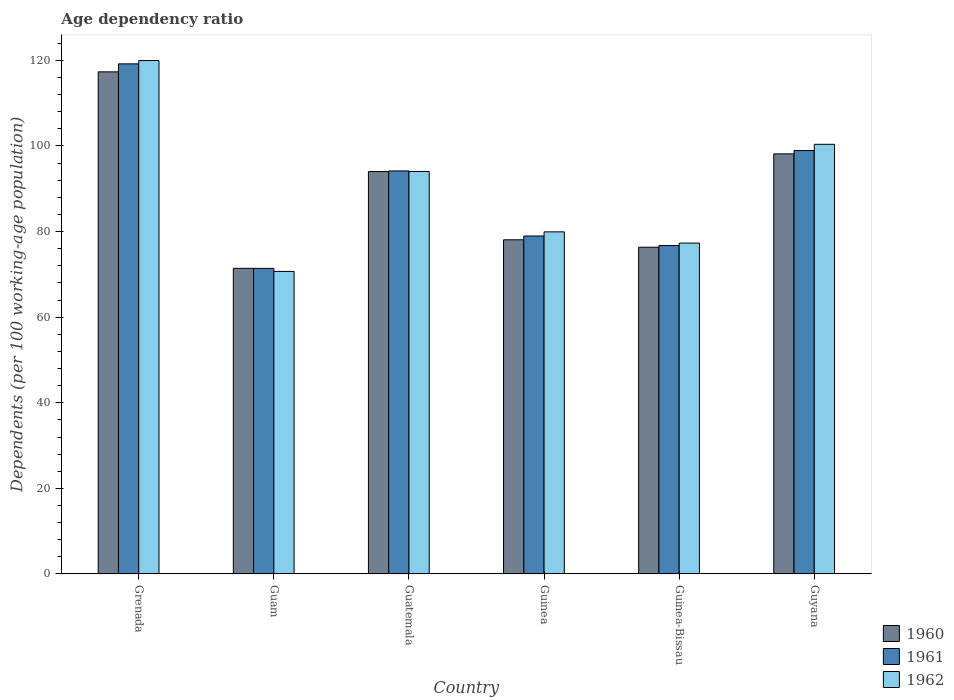How many different coloured bars are there?
Your response must be concise. 3. How many groups of bars are there?
Provide a short and direct response. 6. How many bars are there on the 1st tick from the left?
Offer a terse response. 3. What is the label of the 4th group of bars from the left?
Your answer should be very brief. Guinea. In how many cases, is the number of bars for a given country not equal to the number of legend labels?
Offer a terse response. 0. What is the age dependency ratio in in 1962 in Guinea-Bissau?
Keep it short and to the point. 77.32. Across all countries, what is the maximum age dependency ratio in in 1961?
Provide a short and direct response. 119.19. Across all countries, what is the minimum age dependency ratio in in 1961?
Give a very brief answer. 71.4. In which country was the age dependency ratio in in 1962 maximum?
Your answer should be compact. Grenada. In which country was the age dependency ratio in in 1960 minimum?
Provide a succinct answer. Guam. What is the total age dependency ratio in in 1961 in the graph?
Your answer should be very brief. 539.4. What is the difference between the age dependency ratio in in 1962 in Guam and that in Guinea-Bissau?
Your response must be concise. -6.62. What is the difference between the age dependency ratio in in 1962 in Guinea-Bissau and the age dependency ratio in in 1960 in Grenada?
Your answer should be compact. -40.01. What is the average age dependency ratio in in 1961 per country?
Your answer should be very brief. 89.9. What is the difference between the age dependency ratio in of/in 1961 and age dependency ratio in of/in 1960 in Grenada?
Make the answer very short. 1.87. What is the ratio of the age dependency ratio in in 1961 in Guam to that in Guatemala?
Give a very brief answer. 0.76. Is the age dependency ratio in in 1961 in Guinea less than that in Guyana?
Your response must be concise. Yes. What is the difference between the highest and the second highest age dependency ratio in in 1962?
Your answer should be compact. 6.35. What is the difference between the highest and the lowest age dependency ratio in in 1962?
Your answer should be very brief. 49.27. What does the 2nd bar from the right in Guinea represents?
Provide a succinct answer. 1961. Is it the case that in every country, the sum of the age dependency ratio in in 1961 and age dependency ratio in in 1960 is greater than the age dependency ratio in in 1962?
Offer a terse response. Yes. How many bars are there?
Offer a terse response. 18. Are all the bars in the graph horizontal?
Ensure brevity in your answer.  No. How many countries are there in the graph?
Make the answer very short. 6. Does the graph contain grids?
Ensure brevity in your answer.  No. What is the title of the graph?
Offer a very short reply. Age dependency ratio. What is the label or title of the X-axis?
Your answer should be compact. Country. What is the label or title of the Y-axis?
Give a very brief answer. Dependents (per 100 working-age population). What is the Dependents (per 100 working-age population) in 1960 in Grenada?
Ensure brevity in your answer.  117.32. What is the Dependents (per 100 working-age population) in 1961 in Grenada?
Make the answer very short. 119.19. What is the Dependents (per 100 working-age population) of 1962 in Grenada?
Your response must be concise. 119.96. What is the Dependents (per 100 working-age population) in 1960 in Guam?
Make the answer very short. 71.41. What is the Dependents (per 100 working-age population) in 1961 in Guam?
Your response must be concise. 71.4. What is the Dependents (per 100 working-age population) of 1962 in Guam?
Keep it short and to the point. 70.69. What is the Dependents (per 100 working-age population) in 1960 in Guatemala?
Your answer should be compact. 94.02. What is the Dependents (per 100 working-age population) of 1961 in Guatemala?
Keep it short and to the point. 94.17. What is the Dependents (per 100 working-age population) in 1962 in Guatemala?
Give a very brief answer. 94.05. What is the Dependents (per 100 working-age population) in 1960 in Guinea?
Give a very brief answer. 78.08. What is the Dependents (per 100 working-age population) in 1961 in Guinea?
Offer a terse response. 78.97. What is the Dependents (per 100 working-age population) of 1962 in Guinea?
Keep it short and to the point. 79.94. What is the Dependents (per 100 working-age population) of 1960 in Guinea-Bissau?
Keep it short and to the point. 76.34. What is the Dependents (per 100 working-age population) of 1961 in Guinea-Bissau?
Offer a very short reply. 76.74. What is the Dependents (per 100 working-age population) of 1962 in Guinea-Bissau?
Offer a very short reply. 77.32. What is the Dependents (per 100 working-age population) in 1960 in Guyana?
Give a very brief answer. 98.15. What is the Dependents (per 100 working-age population) in 1961 in Guyana?
Provide a short and direct response. 98.93. What is the Dependents (per 100 working-age population) in 1962 in Guyana?
Offer a terse response. 100.39. Across all countries, what is the maximum Dependents (per 100 working-age population) of 1960?
Your response must be concise. 117.32. Across all countries, what is the maximum Dependents (per 100 working-age population) of 1961?
Your answer should be compact. 119.19. Across all countries, what is the maximum Dependents (per 100 working-age population) in 1962?
Keep it short and to the point. 119.96. Across all countries, what is the minimum Dependents (per 100 working-age population) of 1960?
Offer a terse response. 71.41. Across all countries, what is the minimum Dependents (per 100 working-age population) of 1961?
Offer a terse response. 71.4. Across all countries, what is the minimum Dependents (per 100 working-age population) of 1962?
Offer a terse response. 70.69. What is the total Dependents (per 100 working-age population) in 1960 in the graph?
Your answer should be compact. 535.34. What is the total Dependents (per 100 working-age population) of 1961 in the graph?
Keep it short and to the point. 539.4. What is the total Dependents (per 100 working-age population) in 1962 in the graph?
Keep it short and to the point. 542.35. What is the difference between the Dependents (per 100 working-age population) in 1960 in Grenada and that in Guam?
Ensure brevity in your answer.  45.91. What is the difference between the Dependents (per 100 working-age population) in 1961 in Grenada and that in Guam?
Ensure brevity in your answer.  47.79. What is the difference between the Dependents (per 100 working-age population) in 1962 in Grenada and that in Guam?
Your response must be concise. 49.27. What is the difference between the Dependents (per 100 working-age population) of 1960 in Grenada and that in Guatemala?
Your answer should be very brief. 23.3. What is the difference between the Dependents (per 100 working-age population) in 1961 in Grenada and that in Guatemala?
Offer a terse response. 25.02. What is the difference between the Dependents (per 100 working-age population) of 1962 in Grenada and that in Guatemala?
Provide a short and direct response. 25.92. What is the difference between the Dependents (per 100 working-age population) in 1960 in Grenada and that in Guinea?
Your answer should be very brief. 39.24. What is the difference between the Dependents (per 100 working-age population) of 1961 in Grenada and that in Guinea?
Keep it short and to the point. 40.22. What is the difference between the Dependents (per 100 working-age population) of 1962 in Grenada and that in Guinea?
Keep it short and to the point. 40.03. What is the difference between the Dependents (per 100 working-age population) in 1960 in Grenada and that in Guinea-Bissau?
Make the answer very short. 40.98. What is the difference between the Dependents (per 100 working-age population) in 1961 in Grenada and that in Guinea-Bissau?
Keep it short and to the point. 42.46. What is the difference between the Dependents (per 100 working-age population) in 1962 in Grenada and that in Guinea-Bissau?
Keep it short and to the point. 42.65. What is the difference between the Dependents (per 100 working-age population) of 1960 in Grenada and that in Guyana?
Provide a succinct answer. 19.17. What is the difference between the Dependents (per 100 working-age population) in 1961 in Grenada and that in Guyana?
Provide a succinct answer. 20.26. What is the difference between the Dependents (per 100 working-age population) of 1962 in Grenada and that in Guyana?
Offer a very short reply. 19.57. What is the difference between the Dependents (per 100 working-age population) of 1960 in Guam and that in Guatemala?
Your response must be concise. -22.61. What is the difference between the Dependents (per 100 working-age population) of 1961 in Guam and that in Guatemala?
Offer a very short reply. -22.77. What is the difference between the Dependents (per 100 working-age population) in 1962 in Guam and that in Guatemala?
Your answer should be very brief. -23.35. What is the difference between the Dependents (per 100 working-age population) of 1960 in Guam and that in Guinea?
Make the answer very short. -6.67. What is the difference between the Dependents (per 100 working-age population) in 1961 in Guam and that in Guinea?
Keep it short and to the point. -7.57. What is the difference between the Dependents (per 100 working-age population) in 1962 in Guam and that in Guinea?
Offer a terse response. -9.24. What is the difference between the Dependents (per 100 working-age population) of 1960 in Guam and that in Guinea-Bissau?
Provide a succinct answer. -4.93. What is the difference between the Dependents (per 100 working-age population) in 1961 in Guam and that in Guinea-Bissau?
Provide a succinct answer. -5.33. What is the difference between the Dependents (per 100 working-age population) of 1962 in Guam and that in Guinea-Bissau?
Your response must be concise. -6.62. What is the difference between the Dependents (per 100 working-age population) in 1960 in Guam and that in Guyana?
Provide a succinct answer. -26.74. What is the difference between the Dependents (per 100 working-age population) in 1961 in Guam and that in Guyana?
Keep it short and to the point. -27.53. What is the difference between the Dependents (per 100 working-age population) in 1962 in Guam and that in Guyana?
Ensure brevity in your answer.  -29.7. What is the difference between the Dependents (per 100 working-age population) of 1960 in Guatemala and that in Guinea?
Your response must be concise. 15.94. What is the difference between the Dependents (per 100 working-age population) in 1961 in Guatemala and that in Guinea?
Make the answer very short. 15.2. What is the difference between the Dependents (per 100 working-age population) in 1962 in Guatemala and that in Guinea?
Your response must be concise. 14.11. What is the difference between the Dependents (per 100 working-age population) of 1960 in Guatemala and that in Guinea-Bissau?
Give a very brief answer. 17.68. What is the difference between the Dependents (per 100 working-age population) in 1961 in Guatemala and that in Guinea-Bissau?
Give a very brief answer. 17.44. What is the difference between the Dependents (per 100 working-age population) in 1962 in Guatemala and that in Guinea-Bissau?
Provide a succinct answer. 16.73. What is the difference between the Dependents (per 100 working-age population) in 1960 in Guatemala and that in Guyana?
Offer a very short reply. -4.13. What is the difference between the Dependents (per 100 working-age population) in 1961 in Guatemala and that in Guyana?
Provide a succinct answer. -4.76. What is the difference between the Dependents (per 100 working-age population) of 1962 in Guatemala and that in Guyana?
Offer a terse response. -6.35. What is the difference between the Dependents (per 100 working-age population) in 1960 in Guinea and that in Guinea-Bissau?
Your answer should be compact. 1.74. What is the difference between the Dependents (per 100 working-age population) in 1961 in Guinea and that in Guinea-Bissau?
Give a very brief answer. 2.24. What is the difference between the Dependents (per 100 working-age population) of 1962 in Guinea and that in Guinea-Bissau?
Provide a succinct answer. 2.62. What is the difference between the Dependents (per 100 working-age population) in 1960 in Guinea and that in Guyana?
Offer a terse response. -20.07. What is the difference between the Dependents (per 100 working-age population) of 1961 in Guinea and that in Guyana?
Offer a very short reply. -19.96. What is the difference between the Dependents (per 100 working-age population) of 1962 in Guinea and that in Guyana?
Ensure brevity in your answer.  -20.46. What is the difference between the Dependents (per 100 working-age population) in 1960 in Guinea-Bissau and that in Guyana?
Give a very brief answer. -21.81. What is the difference between the Dependents (per 100 working-age population) in 1961 in Guinea-Bissau and that in Guyana?
Make the answer very short. -22.19. What is the difference between the Dependents (per 100 working-age population) of 1962 in Guinea-Bissau and that in Guyana?
Provide a succinct answer. -23.08. What is the difference between the Dependents (per 100 working-age population) in 1960 in Grenada and the Dependents (per 100 working-age population) in 1961 in Guam?
Provide a short and direct response. 45.92. What is the difference between the Dependents (per 100 working-age population) in 1960 in Grenada and the Dependents (per 100 working-age population) in 1962 in Guam?
Make the answer very short. 46.63. What is the difference between the Dependents (per 100 working-age population) in 1961 in Grenada and the Dependents (per 100 working-age population) in 1962 in Guam?
Your answer should be very brief. 48.5. What is the difference between the Dependents (per 100 working-age population) of 1960 in Grenada and the Dependents (per 100 working-age population) of 1961 in Guatemala?
Keep it short and to the point. 23.15. What is the difference between the Dependents (per 100 working-age population) of 1960 in Grenada and the Dependents (per 100 working-age population) of 1962 in Guatemala?
Your answer should be very brief. 23.28. What is the difference between the Dependents (per 100 working-age population) of 1961 in Grenada and the Dependents (per 100 working-age population) of 1962 in Guatemala?
Ensure brevity in your answer.  25.14. What is the difference between the Dependents (per 100 working-age population) in 1960 in Grenada and the Dependents (per 100 working-age population) in 1961 in Guinea?
Provide a short and direct response. 38.35. What is the difference between the Dependents (per 100 working-age population) of 1960 in Grenada and the Dependents (per 100 working-age population) of 1962 in Guinea?
Give a very brief answer. 37.39. What is the difference between the Dependents (per 100 working-age population) of 1961 in Grenada and the Dependents (per 100 working-age population) of 1962 in Guinea?
Offer a very short reply. 39.25. What is the difference between the Dependents (per 100 working-age population) of 1960 in Grenada and the Dependents (per 100 working-age population) of 1961 in Guinea-Bissau?
Offer a terse response. 40.59. What is the difference between the Dependents (per 100 working-age population) of 1960 in Grenada and the Dependents (per 100 working-age population) of 1962 in Guinea-Bissau?
Offer a very short reply. 40.01. What is the difference between the Dependents (per 100 working-age population) in 1961 in Grenada and the Dependents (per 100 working-age population) in 1962 in Guinea-Bissau?
Make the answer very short. 41.87. What is the difference between the Dependents (per 100 working-age population) of 1960 in Grenada and the Dependents (per 100 working-age population) of 1961 in Guyana?
Give a very brief answer. 18.39. What is the difference between the Dependents (per 100 working-age population) in 1960 in Grenada and the Dependents (per 100 working-age population) in 1962 in Guyana?
Your answer should be very brief. 16.93. What is the difference between the Dependents (per 100 working-age population) of 1961 in Grenada and the Dependents (per 100 working-age population) of 1962 in Guyana?
Give a very brief answer. 18.8. What is the difference between the Dependents (per 100 working-age population) in 1960 in Guam and the Dependents (per 100 working-age population) in 1961 in Guatemala?
Ensure brevity in your answer.  -22.76. What is the difference between the Dependents (per 100 working-age population) in 1960 in Guam and the Dependents (per 100 working-age population) in 1962 in Guatemala?
Your answer should be compact. -22.63. What is the difference between the Dependents (per 100 working-age population) in 1961 in Guam and the Dependents (per 100 working-age population) in 1962 in Guatemala?
Offer a terse response. -22.64. What is the difference between the Dependents (per 100 working-age population) of 1960 in Guam and the Dependents (per 100 working-age population) of 1961 in Guinea?
Your response must be concise. -7.56. What is the difference between the Dependents (per 100 working-age population) in 1960 in Guam and the Dependents (per 100 working-age population) in 1962 in Guinea?
Make the answer very short. -8.52. What is the difference between the Dependents (per 100 working-age population) in 1961 in Guam and the Dependents (per 100 working-age population) in 1962 in Guinea?
Make the answer very short. -8.53. What is the difference between the Dependents (per 100 working-age population) in 1960 in Guam and the Dependents (per 100 working-age population) in 1961 in Guinea-Bissau?
Provide a succinct answer. -5.32. What is the difference between the Dependents (per 100 working-age population) in 1960 in Guam and the Dependents (per 100 working-age population) in 1962 in Guinea-Bissau?
Offer a very short reply. -5.91. What is the difference between the Dependents (per 100 working-age population) of 1961 in Guam and the Dependents (per 100 working-age population) of 1962 in Guinea-Bissau?
Your response must be concise. -5.91. What is the difference between the Dependents (per 100 working-age population) in 1960 in Guam and the Dependents (per 100 working-age population) in 1961 in Guyana?
Make the answer very short. -27.52. What is the difference between the Dependents (per 100 working-age population) of 1960 in Guam and the Dependents (per 100 working-age population) of 1962 in Guyana?
Your answer should be compact. -28.98. What is the difference between the Dependents (per 100 working-age population) of 1961 in Guam and the Dependents (per 100 working-age population) of 1962 in Guyana?
Give a very brief answer. -28.99. What is the difference between the Dependents (per 100 working-age population) in 1960 in Guatemala and the Dependents (per 100 working-age population) in 1961 in Guinea?
Make the answer very short. 15.05. What is the difference between the Dependents (per 100 working-age population) of 1960 in Guatemala and the Dependents (per 100 working-age population) of 1962 in Guinea?
Keep it short and to the point. 14.09. What is the difference between the Dependents (per 100 working-age population) of 1961 in Guatemala and the Dependents (per 100 working-age population) of 1962 in Guinea?
Your answer should be very brief. 14.23. What is the difference between the Dependents (per 100 working-age population) of 1960 in Guatemala and the Dependents (per 100 working-age population) of 1961 in Guinea-Bissau?
Your answer should be compact. 17.29. What is the difference between the Dependents (per 100 working-age population) in 1960 in Guatemala and the Dependents (per 100 working-age population) in 1962 in Guinea-Bissau?
Your response must be concise. 16.7. What is the difference between the Dependents (per 100 working-age population) in 1961 in Guatemala and the Dependents (per 100 working-age population) in 1962 in Guinea-Bissau?
Your answer should be compact. 16.85. What is the difference between the Dependents (per 100 working-age population) of 1960 in Guatemala and the Dependents (per 100 working-age population) of 1961 in Guyana?
Offer a very short reply. -4.91. What is the difference between the Dependents (per 100 working-age population) in 1960 in Guatemala and the Dependents (per 100 working-age population) in 1962 in Guyana?
Your response must be concise. -6.37. What is the difference between the Dependents (per 100 working-age population) of 1961 in Guatemala and the Dependents (per 100 working-age population) of 1962 in Guyana?
Make the answer very short. -6.22. What is the difference between the Dependents (per 100 working-age population) of 1960 in Guinea and the Dependents (per 100 working-age population) of 1961 in Guinea-Bissau?
Make the answer very short. 1.35. What is the difference between the Dependents (per 100 working-age population) of 1960 in Guinea and the Dependents (per 100 working-age population) of 1962 in Guinea-Bissau?
Ensure brevity in your answer.  0.77. What is the difference between the Dependents (per 100 working-age population) in 1961 in Guinea and the Dependents (per 100 working-age population) in 1962 in Guinea-Bissau?
Offer a very short reply. 1.65. What is the difference between the Dependents (per 100 working-age population) in 1960 in Guinea and the Dependents (per 100 working-age population) in 1961 in Guyana?
Offer a very short reply. -20.85. What is the difference between the Dependents (per 100 working-age population) of 1960 in Guinea and the Dependents (per 100 working-age population) of 1962 in Guyana?
Give a very brief answer. -22.31. What is the difference between the Dependents (per 100 working-age population) of 1961 in Guinea and the Dependents (per 100 working-age population) of 1962 in Guyana?
Ensure brevity in your answer.  -21.42. What is the difference between the Dependents (per 100 working-age population) of 1960 in Guinea-Bissau and the Dependents (per 100 working-age population) of 1961 in Guyana?
Your response must be concise. -22.59. What is the difference between the Dependents (per 100 working-age population) in 1960 in Guinea-Bissau and the Dependents (per 100 working-age population) in 1962 in Guyana?
Offer a terse response. -24.05. What is the difference between the Dependents (per 100 working-age population) in 1961 in Guinea-Bissau and the Dependents (per 100 working-age population) in 1962 in Guyana?
Make the answer very short. -23.66. What is the average Dependents (per 100 working-age population) of 1960 per country?
Provide a succinct answer. 89.22. What is the average Dependents (per 100 working-age population) in 1961 per country?
Make the answer very short. 89.9. What is the average Dependents (per 100 working-age population) in 1962 per country?
Make the answer very short. 90.39. What is the difference between the Dependents (per 100 working-age population) in 1960 and Dependents (per 100 working-age population) in 1961 in Grenada?
Your answer should be compact. -1.87. What is the difference between the Dependents (per 100 working-age population) in 1960 and Dependents (per 100 working-age population) in 1962 in Grenada?
Keep it short and to the point. -2.64. What is the difference between the Dependents (per 100 working-age population) in 1961 and Dependents (per 100 working-age population) in 1962 in Grenada?
Provide a short and direct response. -0.77. What is the difference between the Dependents (per 100 working-age population) in 1960 and Dependents (per 100 working-age population) in 1961 in Guam?
Ensure brevity in your answer.  0.01. What is the difference between the Dependents (per 100 working-age population) of 1960 and Dependents (per 100 working-age population) of 1962 in Guam?
Offer a terse response. 0.72. What is the difference between the Dependents (per 100 working-age population) of 1961 and Dependents (per 100 working-age population) of 1962 in Guam?
Your answer should be very brief. 0.71. What is the difference between the Dependents (per 100 working-age population) of 1960 and Dependents (per 100 working-age population) of 1961 in Guatemala?
Your answer should be compact. -0.15. What is the difference between the Dependents (per 100 working-age population) in 1960 and Dependents (per 100 working-age population) in 1962 in Guatemala?
Your response must be concise. -0.02. What is the difference between the Dependents (per 100 working-age population) in 1961 and Dependents (per 100 working-age population) in 1962 in Guatemala?
Your answer should be very brief. 0.12. What is the difference between the Dependents (per 100 working-age population) in 1960 and Dependents (per 100 working-age population) in 1961 in Guinea?
Your answer should be very brief. -0.89. What is the difference between the Dependents (per 100 working-age population) of 1960 and Dependents (per 100 working-age population) of 1962 in Guinea?
Keep it short and to the point. -1.85. What is the difference between the Dependents (per 100 working-age population) of 1961 and Dependents (per 100 working-age population) of 1962 in Guinea?
Offer a very short reply. -0.97. What is the difference between the Dependents (per 100 working-age population) of 1960 and Dependents (per 100 working-age population) of 1961 in Guinea-Bissau?
Your answer should be very brief. -0.39. What is the difference between the Dependents (per 100 working-age population) in 1960 and Dependents (per 100 working-age population) in 1962 in Guinea-Bissau?
Ensure brevity in your answer.  -0.97. What is the difference between the Dependents (per 100 working-age population) of 1961 and Dependents (per 100 working-age population) of 1962 in Guinea-Bissau?
Keep it short and to the point. -0.58. What is the difference between the Dependents (per 100 working-age population) in 1960 and Dependents (per 100 working-age population) in 1961 in Guyana?
Offer a very short reply. -0.78. What is the difference between the Dependents (per 100 working-age population) of 1960 and Dependents (per 100 working-age population) of 1962 in Guyana?
Ensure brevity in your answer.  -2.24. What is the difference between the Dependents (per 100 working-age population) in 1961 and Dependents (per 100 working-age population) in 1962 in Guyana?
Give a very brief answer. -1.46. What is the ratio of the Dependents (per 100 working-age population) of 1960 in Grenada to that in Guam?
Ensure brevity in your answer.  1.64. What is the ratio of the Dependents (per 100 working-age population) of 1961 in Grenada to that in Guam?
Provide a short and direct response. 1.67. What is the ratio of the Dependents (per 100 working-age population) in 1962 in Grenada to that in Guam?
Make the answer very short. 1.7. What is the ratio of the Dependents (per 100 working-age population) of 1960 in Grenada to that in Guatemala?
Keep it short and to the point. 1.25. What is the ratio of the Dependents (per 100 working-age population) in 1961 in Grenada to that in Guatemala?
Ensure brevity in your answer.  1.27. What is the ratio of the Dependents (per 100 working-age population) of 1962 in Grenada to that in Guatemala?
Ensure brevity in your answer.  1.28. What is the ratio of the Dependents (per 100 working-age population) of 1960 in Grenada to that in Guinea?
Your response must be concise. 1.5. What is the ratio of the Dependents (per 100 working-age population) in 1961 in Grenada to that in Guinea?
Keep it short and to the point. 1.51. What is the ratio of the Dependents (per 100 working-age population) of 1962 in Grenada to that in Guinea?
Offer a terse response. 1.5. What is the ratio of the Dependents (per 100 working-age population) in 1960 in Grenada to that in Guinea-Bissau?
Offer a terse response. 1.54. What is the ratio of the Dependents (per 100 working-age population) of 1961 in Grenada to that in Guinea-Bissau?
Your answer should be very brief. 1.55. What is the ratio of the Dependents (per 100 working-age population) of 1962 in Grenada to that in Guinea-Bissau?
Make the answer very short. 1.55. What is the ratio of the Dependents (per 100 working-age population) in 1960 in Grenada to that in Guyana?
Provide a short and direct response. 1.2. What is the ratio of the Dependents (per 100 working-age population) of 1961 in Grenada to that in Guyana?
Offer a terse response. 1.2. What is the ratio of the Dependents (per 100 working-age population) of 1962 in Grenada to that in Guyana?
Make the answer very short. 1.19. What is the ratio of the Dependents (per 100 working-age population) in 1960 in Guam to that in Guatemala?
Give a very brief answer. 0.76. What is the ratio of the Dependents (per 100 working-age population) in 1961 in Guam to that in Guatemala?
Your answer should be compact. 0.76. What is the ratio of the Dependents (per 100 working-age population) of 1962 in Guam to that in Guatemala?
Your response must be concise. 0.75. What is the ratio of the Dependents (per 100 working-age population) of 1960 in Guam to that in Guinea?
Your answer should be compact. 0.91. What is the ratio of the Dependents (per 100 working-age population) of 1961 in Guam to that in Guinea?
Provide a succinct answer. 0.9. What is the ratio of the Dependents (per 100 working-age population) of 1962 in Guam to that in Guinea?
Make the answer very short. 0.88. What is the ratio of the Dependents (per 100 working-age population) in 1960 in Guam to that in Guinea-Bissau?
Your answer should be compact. 0.94. What is the ratio of the Dependents (per 100 working-age population) in 1961 in Guam to that in Guinea-Bissau?
Give a very brief answer. 0.93. What is the ratio of the Dependents (per 100 working-age population) of 1962 in Guam to that in Guinea-Bissau?
Your response must be concise. 0.91. What is the ratio of the Dependents (per 100 working-age population) of 1960 in Guam to that in Guyana?
Keep it short and to the point. 0.73. What is the ratio of the Dependents (per 100 working-age population) in 1961 in Guam to that in Guyana?
Ensure brevity in your answer.  0.72. What is the ratio of the Dependents (per 100 working-age population) in 1962 in Guam to that in Guyana?
Your answer should be compact. 0.7. What is the ratio of the Dependents (per 100 working-age population) of 1960 in Guatemala to that in Guinea?
Keep it short and to the point. 1.2. What is the ratio of the Dependents (per 100 working-age population) of 1961 in Guatemala to that in Guinea?
Your answer should be very brief. 1.19. What is the ratio of the Dependents (per 100 working-age population) of 1962 in Guatemala to that in Guinea?
Your answer should be very brief. 1.18. What is the ratio of the Dependents (per 100 working-age population) of 1960 in Guatemala to that in Guinea-Bissau?
Your answer should be very brief. 1.23. What is the ratio of the Dependents (per 100 working-age population) of 1961 in Guatemala to that in Guinea-Bissau?
Provide a succinct answer. 1.23. What is the ratio of the Dependents (per 100 working-age population) of 1962 in Guatemala to that in Guinea-Bissau?
Provide a succinct answer. 1.22. What is the ratio of the Dependents (per 100 working-age population) of 1960 in Guatemala to that in Guyana?
Keep it short and to the point. 0.96. What is the ratio of the Dependents (per 100 working-age population) of 1961 in Guatemala to that in Guyana?
Give a very brief answer. 0.95. What is the ratio of the Dependents (per 100 working-age population) of 1962 in Guatemala to that in Guyana?
Give a very brief answer. 0.94. What is the ratio of the Dependents (per 100 working-age population) of 1960 in Guinea to that in Guinea-Bissau?
Give a very brief answer. 1.02. What is the ratio of the Dependents (per 100 working-age population) of 1961 in Guinea to that in Guinea-Bissau?
Your response must be concise. 1.03. What is the ratio of the Dependents (per 100 working-age population) of 1962 in Guinea to that in Guinea-Bissau?
Offer a terse response. 1.03. What is the ratio of the Dependents (per 100 working-age population) of 1960 in Guinea to that in Guyana?
Your answer should be very brief. 0.8. What is the ratio of the Dependents (per 100 working-age population) of 1961 in Guinea to that in Guyana?
Offer a very short reply. 0.8. What is the ratio of the Dependents (per 100 working-age population) of 1962 in Guinea to that in Guyana?
Give a very brief answer. 0.8. What is the ratio of the Dependents (per 100 working-age population) in 1961 in Guinea-Bissau to that in Guyana?
Provide a short and direct response. 0.78. What is the ratio of the Dependents (per 100 working-age population) in 1962 in Guinea-Bissau to that in Guyana?
Your answer should be compact. 0.77. What is the difference between the highest and the second highest Dependents (per 100 working-age population) in 1960?
Offer a terse response. 19.17. What is the difference between the highest and the second highest Dependents (per 100 working-age population) in 1961?
Offer a terse response. 20.26. What is the difference between the highest and the second highest Dependents (per 100 working-age population) in 1962?
Make the answer very short. 19.57. What is the difference between the highest and the lowest Dependents (per 100 working-age population) in 1960?
Offer a very short reply. 45.91. What is the difference between the highest and the lowest Dependents (per 100 working-age population) in 1961?
Your response must be concise. 47.79. What is the difference between the highest and the lowest Dependents (per 100 working-age population) of 1962?
Make the answer very short. 49.27. 